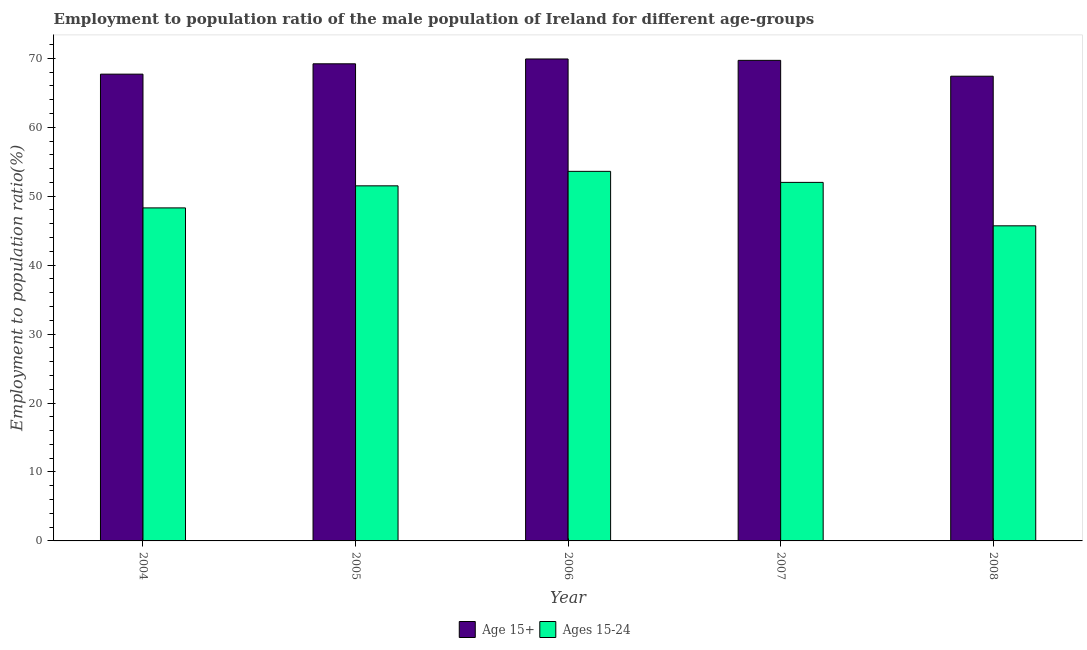How many different coloured bars are there?
Your response must be concise. 2. How many groups of bars are there?
Keep it short and to the point. 5. Are the number of bars on each tick of the X-axis equal?
Offer a terse response. Yes. In how many cases, is the number of bars for a given year not equal to the number of legend labels?
Provide a succinct answer. 0. What is the employment to population ratio(age 15+) in 2008?
Your answer should be compact. 67.4. Across all years, what is the maximum employment to population ratio(age 15+)?
Your response must be concise. 69.9. Across all years, what is the minimum employment to population ratio(age 15+)?
Make the answer very short. 67.4. In which year was the employment to population ratio(age 15-24) maximum?
Offer a very short reply. 2006. In which year was the employment to population ratio(age 15-24) minimum?
Keep it short and to the point. 2008. What is the total employment to population ratio(age 15-24) in the graph?
Keep it short and to the point. 251.1. What is the difference between the employment to population ratio(age 15-24) in 2005 and that in 2008?
Provide a short and direct response. 5.8. What is the difference between the employment to population ratio(age 15-24) in 2005 and the employment to population ratio(age 15+) in 2008?
Keep it short and to the point. 5.8. What is the average employment to population ratio(age 15+) per year?
Your answer should be compact. 68.78. In the year 2006, what is the difference between the employment to population ratio(age 15+) and employment to population ratio(age 15-24)?
Your response must be concise. 0. What is the ratio of the employment to population ratio(age 15-24) in 2004 to that in 2008?
Keep it short and to the point. 1.06. Is the difference between the employment to population ratio(age 15-24) in 2005 and 2006 greater than the difference between the employment to population ratio(age 15+) in 2005 and 2006?
Your response must be concise. No. What is the difference between the highest and the second highest employment to population ratio(age 15+)?
Your answer should be very brief. 0.2. What is the difference between the highest and the lowest employment to population ratio(age 15+)?
Your answer should be compact. 2.5. What does the 2nd bar from the left in 2005 represents?
Provide a succinct answer. Ages 15-24. What does the 1st bar from the right in 2006 represents?
Make the answer very short. Ages 15-24. How many bars are there?
Your response must be concise. 10. What is the difference between two consecutive major ticks on the Y-axis?
Provide a succinct answer. 10. Does the graph contain grids?
Make the answer very short. No. What is the title of the graph?
Provide a succinct answer. Employment to population ratio of the male population of Ireland for different age-groups. Does "Central government" appear as one of the legend labels in the graph?
Make the answer very short. No. What is the Employment to population ratio(%) of Age 15+ in 2004?
Keep it short and to the point. 67.7. What is the Employment to population ratio(%) in Ages 15-24 in 2004?
Your answer should be very brief. 48.3. What is the Employment to population ratio(%) in Age 15+ in 2005?
Your response must be concise. 69.2. What is the Employment to population ratio(%) in Ages 15-24 in 2005?
Keep it short and to the point. 51.5. What is the Employment to population ratio(%) in Age 15+ in 2006?
Your answer should be compact. 69.9. What is the Employment to population ratio(%) in Ages 15-24 in 2006?
Your answer should be very brief. 53.6. What is the Employment to population ratio(%) of Age 15+ in 2007?
Make the answer very short. 69.7. What is the Employment to population ratio(%) of Age 15+ in 2008?
Give a very brief answer. 67.4. What is the Employment to population ratio(%) in Ages 15-24 in 2008?
Ensure brevity in your answer.  45.7. Across all years, what is the maximum Employment to population ratio(%) of Age 15+?
Offer a very short reply. 69.9. Across all years, what is the maximum Employment to population ratio(%) in Ages 15-24?
Your answer should be very brief. 53.6. Across all years, what is the minimum Employment to population ratio(%) of Age 15+?
Provide a succinct answer. 67.4. Across all years, what is the minimum Employment to population ratio(%) in Ages 15-24?
Your answer should be very brief. 45.7. What is the total Employment to population ratio(%) in Age 15+ in the graph?
Your answer should be compact. 343.9. What is the total Employment to population ratio(%) of Ages 15-24 in the graph?
Offer a terse response. 251.1. What is the difference between the Employment to population ratio(%) in Ages 15-24 in 2004 and that in 2005?
Provide a succinct answer. -3.2. What is the difference between the Employment to population ratio(%) in Age 15+ in 2004 and that in 2006?
Ensure brevity in your answer.  -2.2. What is the difference between the Employment to population ratio(%) in Age 15+ in 2004 and that in 2007?
Your answer should be compact. -2. What is the difference between the Employment to population ratio(%) of Age 15+ in 2004 and that in 2008?
Provide a short and direct response. 0.3. What is the difference between the Employment to population ratio(%) in Ages 15-24 in 2005 and that in 2006?
Your answer should be compact. -2.1. What is the difference between the Employment to population ratio(%) of Age 15+ in 2005 and that in 2008?
Make the answer very short. 1.8. What is the difference between the Employment to population ratio(%) of Age 15+ in 2006 and that in 2007?
Give a very brief answer. 0.2. What is the difference between the Employment to population ratio(%) in Ages 15-24 in 2006 and that in 2007?
Provide a short and direct response. 1.6. What is the difference between the Employment to population ratio(%) of Age 15+ in 2006 and that in 2008?
Make the answer very short. 2.5. What is the difference between the Employment to population ratio(%) in Ages 15-24 in 2007 and that in 2008?
Your response must be concise. 6.3. What is the difference between the Employment to population ratio(%) of Age 15+ in 2004 and the Employment to population ratio(%) of Ages 15-24 in 2005?
Provide a succinct answer. 16.2. What is the difference between the Employment to population ratio(%) in Age 15+ in 2004 and the Employment to population ratio(%) in Ages 15-24 in 2008?
Offer a very short reply. 22. What is the difference between the Employment to population ratio(%) in Age 15+ in 2005 and the Employment to population ratio(%) in Ages 15-24 in 2007?
Your answer should be very brief. 17.2. What is the difference between the Employment to population ratio(%) of Age 15+ in 2005 and the Employment to population ratio(%) of Ages 15-24 in 2008?
Give a very brief answer. 23.5. What is the difference between the Employment to population ratio(%) of Age 15+ in 2006 and the Employment to population ratio(%) of Ages 15-24 in 2008?
Your answer should be compact. 24.2. What is the difference between the Employment to population ratio(%) of Age 15+ in 2007 and the Employment to population ratio(%) of Ages 15-24 in 2008?
Keep it short and to the point. 24. What is the average Employment to population ratio(%) in Age 15+ per year?
Offer a terse response. 68.78. What is the average Employment to population ratio(%) of Ages 15-24 per year?
Provide a short and direct response. 50.22. In the year 2004, what is the difference between the Employment to population ratio(%) in Age 15+ and Employment to population ratio(%) in Ages 15-24?
Your response must be concise. 19.4. In the year 2005, what is the difference between the Employment to population ratio(%) of Age 15+ and Employment to population ratio(%) of Ages 15-24?
Your response must be concise. 17.7. In the year 2006, what is the difference between the Employment to population ratio(%) in Age 15+ and Employment to population ratio(%) in Ages 15-24?
Provide a succinct answer. 16.3. In the year 2008, what is the difference between the Employment to population ratio(%) of Age 15+ and Employment to population ratio(%) of Ages 15-24?
Make the answer very short. 21.7. What is the ratio of the Employment to population ratio(%) of Age 15+ in 2004 to that in 2005?
Your answer should be compact. 0.98. What is the ratio of the Employment to population ratio(%) in Ages 15-24 in 2004 to that in 2005?
Keep it short and to the point. 0.94. What is the ratio of the Employment to population ratio(%) in Age 15+ in 2004 to that in 2006?
Provide a succinct answer. 0.97. What is the ratio of the Employment to population ratio(%) in Ages 15-24 in 2004 to that in 2006?
Offer a very short reply. 0.9. What is the ratio of the Employment to population ratio(%) of Age 15+ in 2004 to that in 2007?
Ensure brevity in your answer.  0.97. What is the ratio of the Employment to population ratio(%) in Ages 15-24 in 2004 to that in 2007?
Your answer should be very brief. 0.93. What is the ratio of the Employment to population ratio(%) of Ages 15-24 in 2004 to that in 2008?
Keep it short and to the point. 1.06. What is the ratio of the Employment to population ratio(%) in Age 15+ in 2005 to that in 2006?
Provide a short and direct response. 0.99. What is the ratio of the Employment to population ratio(%) of Ages 15-24 in 2005 to that in 2006?
Provide a succinct answer. 0.96. What is the ratio of the Employment to population ratio(%) in Age 15+ in 2005 to that in 2008?
Offer a terse response. 1.03. What is the ratio of the Employment to population ratio(%) of Ages 15-24 in 2005 to that in 2008?
Offer a terse response. 1.13. What is the ratio of the Employment to population ratio(%) in Age 15+ in 2006 to that in 2007?
Your response must be concise. 1. What is the ratio of the Employment to population ratio(%) in Ages 15-24 in 2006 to that in 2007?
Provide a succinct answer. 1.03. What is the ratio of the Employment to population ratio(%) in Age 15+ in 2006 to that in 2008?
Provide a short and direct response. 1.04. What is the ratio of the Employment to population ratio(%) of Ages 15-24 in 2006 to that in 2008?
Offer a terse response. 1.17. What is the ratio of the Employment to population ratio(%) in Age 15+ in 2007 to that in 2008?
Your answer should be compact. 1.03. What is the ratio of the Employment to population ratio(%) of Ages 15-24 in 2007 to that in 2008?
Your response must be concise. 1.14. 